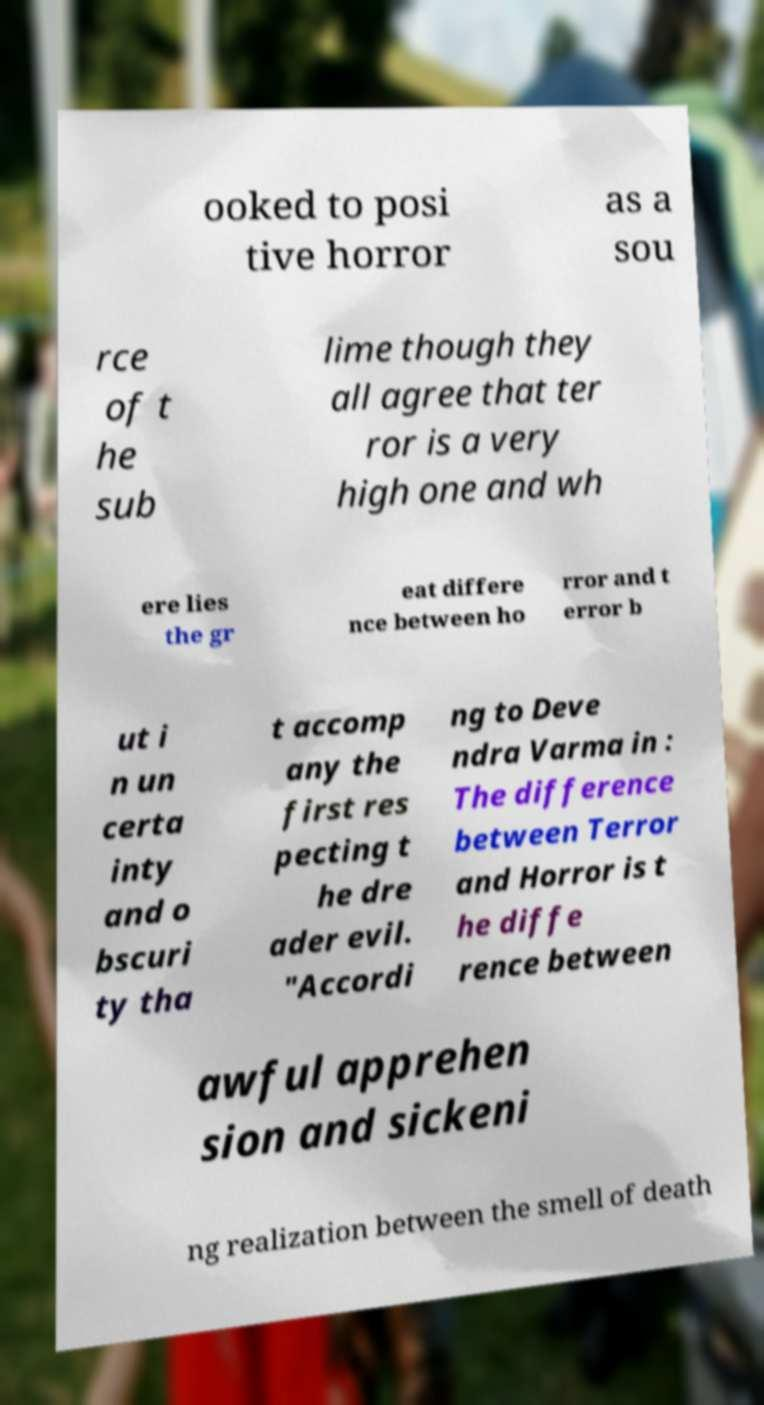Please read and relay the text visible in this image. What does it say? ooked to posi tive horror as a sou rce of t he sub lime though they all agree that ter ror is a very high one and wh ere lies the gr eat differe nce between ho rror and t error b ut i n un certa inty and o bscuri ty tha t accomp any the first res pecting t he dre ader evil. "Accordi ng to Deve ndra Varma in : The difference between Terror and Horror is t he diffe rence between awful apprehen sion and sickeni ng realization between the smell of death 